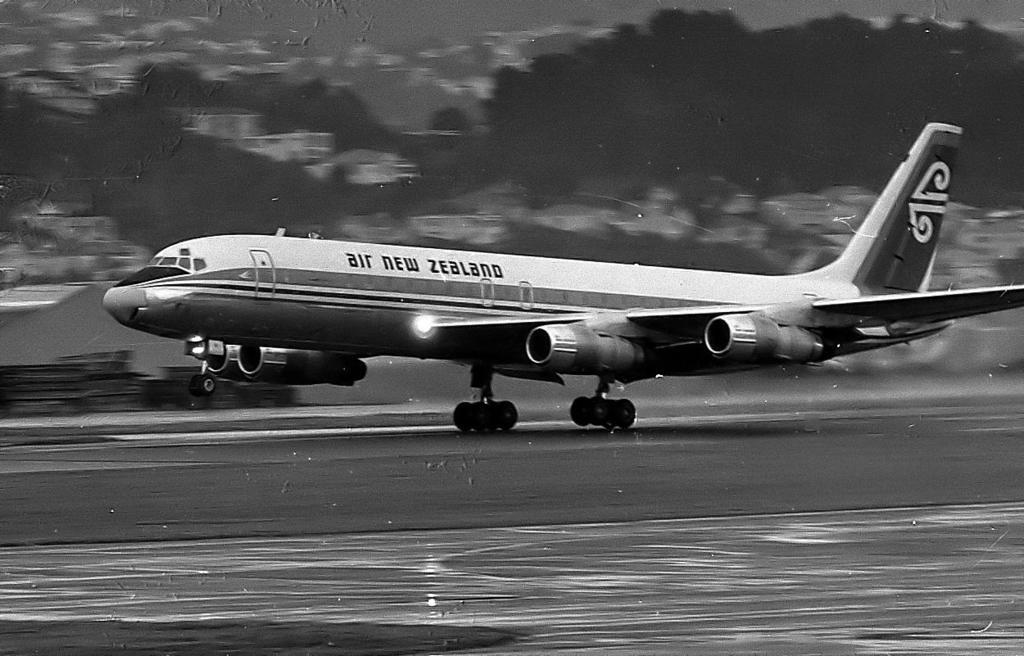<image>
Give a short and clear explanation of the subsequent image. An Air New Zealand plane takes off from a runway. 